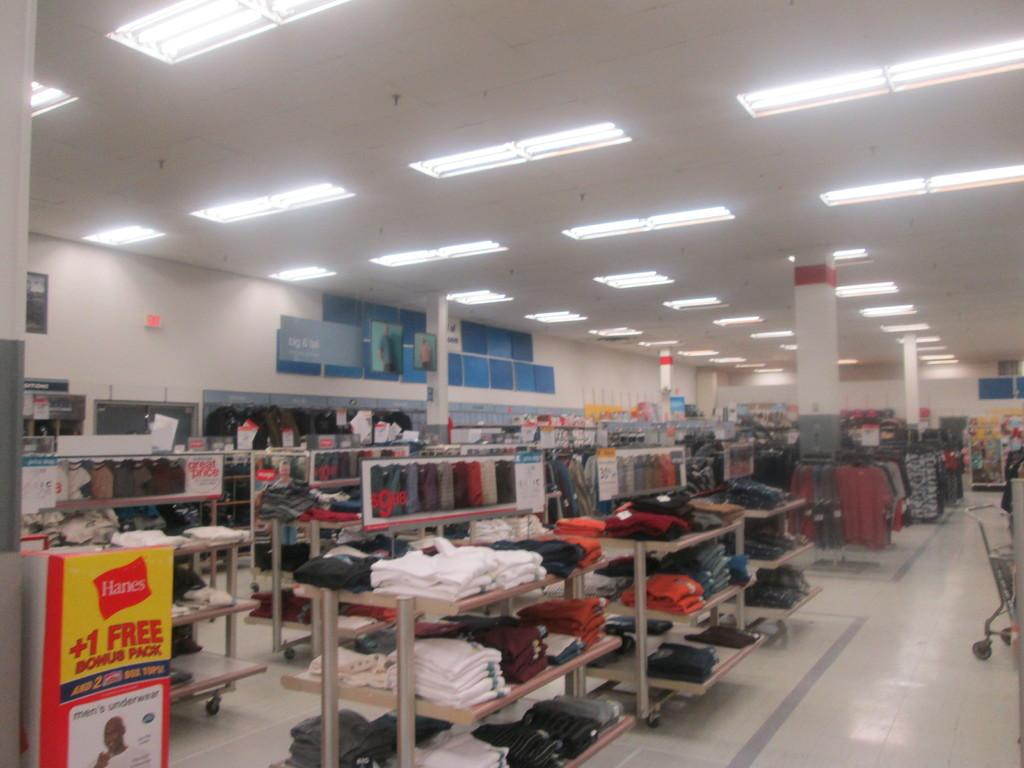<image>
Share a concise interpretation of the image provided. a display of shirts and pants with hanes offering a 1 free bonus pack 